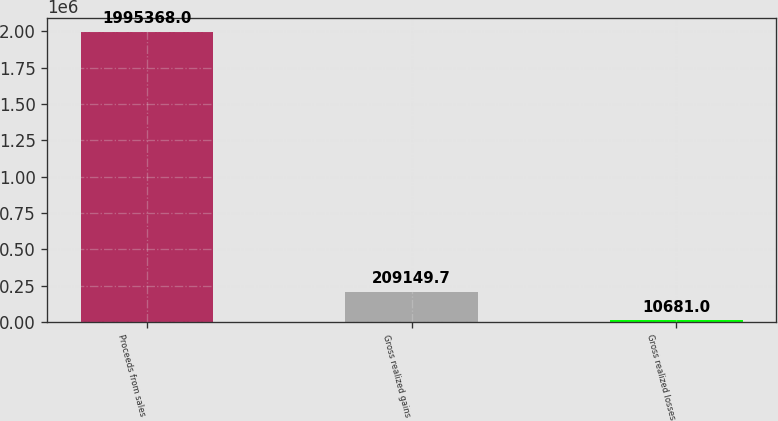Convert chart. <chart><loc_0><loc_0><loc_500><loc_500><bar_chart><fcel>Proceeds from sales<fcel>Gross realized gains<fcel>Gross realized losses<nl><fcel>1.99537e+06<fcel>209150<fcel>10681<nl></chart> 